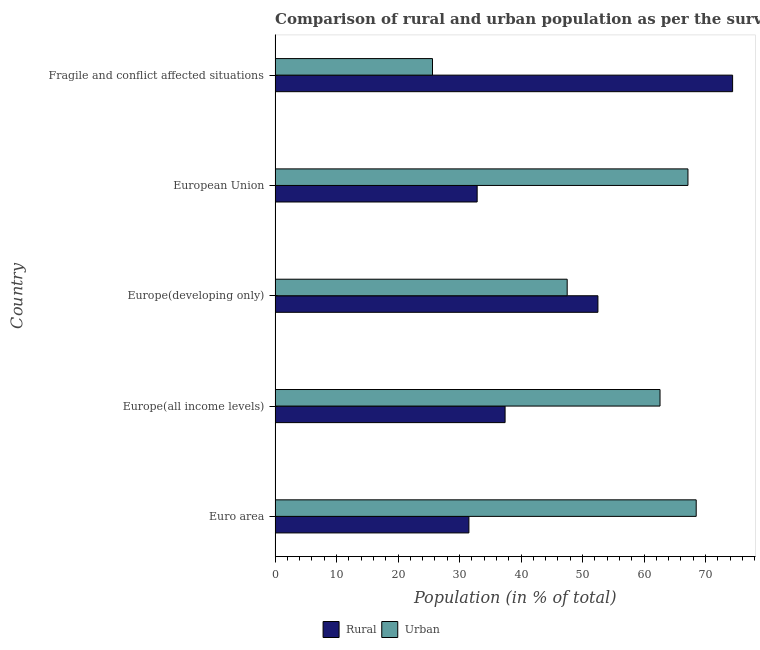How many bars are there on the 2nd tick from the top?
Make the answer very short. 2. What is the label of the 1st group of bars from the top?
Provide a succinct answer. Fragile and conflict affected situations. What is the urban population in European Union?
Provide a succinct answer. 67.14. Across all countries, what is the maximum rural population?
Make the answer very short. 74.4. Across all countries, what is the minimum rural population?
Provide a succinct answer. 31.52. In which country was the rural population maximum?
Offer a very short reply. Fragile and conflict affected situations. What is the total urban population in the graph?
Give a very brief answer. 271.32. What is the difference between the urban population in Europe(developing only) and that in European Union?
Your response must be concise. -19.64. What is the difference between the rural population in Europe(developing only) and the urban population in Fragile and conflict affected situations?
Ensure brevity in your answer.  26.9. What is the average rural population per country?
Provide a succinct answer. 45.74. What is the difference between the urban population and rural population in Europe(all income levels)?
Your answer should be very brief. 25.2. In how many countries, is the urban population greater than 34 %?
Give a very brief answer. 4. What is the ratio of the urban population in Euro area to that in Fragile and conflict affected situations?
Your answer should be very brief. 2.67. Is the difference between the urban population in Euro area and Europe(all income levels) greater than the difference between the rural population in Euro area and Europe(all income levels)?
Offer a terse response. Yes. What is the difference between the highest and the second highest urban population?
Ensure brevity in your answer.  1.34. What is the difference between the highest and the lowest urban population?
Offer a very short reply. 42.88. What does the 1st bar from the top in Europe(developing only) represents?
Ensure brevity in your answer.  Urban. What does the 1st bar from the bottom in Europe(developing only) represents?
Your response must be concise. Rural. What is the difference between two consecutive major ticks on the X-axis?
Provide a succinct answer. 10. Are the values on the major ticks of X-axis written in scientific E-notation?
Your answer should be very brief. No. What is the title of the graph?
Make the answer very short. Comparison of rural and urban population as per the survey in 1974 census. Does "Technicians" appear as one of the legend labels in the graph?
Your answer should be very brief. No. What is the label or title of the X-axis?
Provide a short and direct response. Population (in % of total). What is the label or title of the Y-axis?
Provide a succinct answer. Country. What is the Population (in % of total) of Rural in Euro area?
Give a very brief answer. 31.52. What is the Population (in % of total) in Urban in Euro area?
Provide a short and direct response. 68.48. What is the Population (in % of total) of Rural in Europe(all income levels)?
Make the answer very short. 37.4. What is the Population (in % of total) in Urban in Europe(all income levels)?
Ensure brevity in your answer.  62.6. What is the Population (in % of total) of Rural in Europe(developing only)?
Your answer should be compact. 52.5. What is the Population (in % of total) in Urban in Europe(developing only)?
Your answer should be very brief. 47.5. What is the Population (in % of total) of Rural in European Union?
Your answer should be very brief. 32.86. What is the Population (in % of total) of Urban in European Union?
Provide a short and direct response. 67.14. What is the Population (in % of total) of Rural in Fragile and conflict affected situations?
Make the answer very short. 74.4. What is the Population (in % of total) in Urban in Fragile and conflict affected situations?
Ensure brevity in your answer.  25.6. Across all countries, what is the maximum Population (in % of total) in Rural?
Keep it short and to the point. 74.4. Across all countries, what is the maximum Population (in % of total) of Urban?
Offer a terse response. 68.48. Across all countries, what is the minimum Population (in % of total) of Rural?
Make the answer very short. 31.52. Across all countries, what is the minimum Population (in % of total) of Urban?
Keep it short and to the point. 25.6. What is the total Population (in % of total) of Rural in the graph?
Offer a terse response. 228.68. What is the total Population (in % of total) in Urban in the graph?
Give a very brief answer. 271.32. What is the difference between the Population (in % of total) of Rural in Euro area and that in Europe(all income levels)?
Provide a short and direct response. -5.88. What is the difference between the Population (in % of total) in Urban in Euro area and that in Europe(all income levels)?
Offer a terse response. 5.88. What is the difference between the Population (in % of total) of Rural in Euro area and that in Europe(developing only)?
Offer a terse response. -20.98. What is the difference between the Population (in % of total) in Urban in Euro area and that in Europe(developing only)?
Offer a very short reply. 20.98. What is the difference between the Population (in % of total) in Rural in Euro area and that in European Union?
Provide a short and direct response. -1.34. What is the difference between the Population (in % of total) of Urban in Euro area and that in European Union?
Make the answer very short. 1.34. What is the difference between the Population (in % of total) in Rural in Euro area and that in Fragile and conflict affected situations?
Offer a very short reply. -42.88. What is the difference between the Population (in % of total) in Urban in Euro area and that in Fragile and conflict affected situations?
Provide a succinct answer. 42.88. What is the difference between the Population (in % of total) of Rural in Europe(all income levels) and that in Europe(developing only)?
Your answer should be compact. -15.1. What is the difference between the Population (in % of total) in Urban in Europe(all income levels) and that in Europe(developing only)?
Offer a terse response. 15.1. What is the difference between the Population (in % of total) in Rural in Europe(all income levels) and that in European Union?
Offer a very short reply. 4.54. What is the difference between the Population (in % of total) in Urban in Europe(all income levels) and that in European Union?
Offer a terse response. -4.54. What is the difference between the Population (in % of total) in Rural in Europe(all income levels) and that in Fragile and conflict affected situations?
Offer a very short reply. -37. What is the difference between the Population (in % of total) of Urban in Europe(all income levels) and that in Fragile and conflict affected situations?
Provide a short and direct response. 37. What is the difference between the Population (in % of total) in Rural in Europe(developing only) and that in European Union?
Your answer should be very brief. 19.64. What is the difference between the Population (in % of total) of Urban in Europe(developing only) and that in European Union?
Your response must be concise. -19.64. What is the difference between the Population (in % of total) of Rural in Europe(developing only) and that in Fragile and conflict affected situations?
Offer a terse response. -21.9. What is the difference between the Population (in % of total) in Urban in Europe(developing only) and that in Fragile and conflict affected situations?
Your answer should be very brief. 21.9. What is the difference between the Population (in % of total) in Rural in European Union and that in Fragile and conflict affected situations?
Provide a short and direct response. -41.54. What is the difference between the Population (in % of total) in Urban in European Union and that in Fragile and conflict affected situations?
Ensure brevity in your answer.  41.54. What is the difference between the Population (in % of total) of Rural in Euro area and the Population (in % of total) of Urban in Europe(all income levels)?
Offer a terse response. -31.08. What is the difference between the Population (in % of total) in Rural in Euro area and the Population (in % of total) in Urban in Europe(developing only)?
Keep it short and to the point. -15.98. What is the difference between the Population (in % of total) in Rural in Euro area and the Population (in % of total) in Urban in European Union?
Your response must be concise. -35.62. What is the difference between the Population (in % of total) of Rural in Euro area and the Population (in % of total) of Urban in Fragile and conflict affected situations?
Your answer should be very brief. 5.92. What is the difference between the Population (in % of total) of Rural in Europe(all income levels) and the Population (in % of total) of Urban in Europe(developing only)?
Give a very brief answer. -10.1. What is the difference between the Population (in % of total) in Rural in Europe(all income levels) and the Population (in % of total) in Urban in European Union?
Your answer should be compact. -29.74. What is the difference between the Population (in % of total) of Rural in Europe(all income levels) and the Population (in % of total) of Urban in Fragile and conflict affected situations?
Keep it short and to the point. 11.8. What is the difference between the Population (in % of total) in Rural in Europe(developing only) and the Population (in % of total) in Urban in European Union?
Provide a short and direct response. -14.64. What is the difference between the Population (in % of total) in Rural in Europe(developing only) and the Population (in % of total) in Urban in Fragile and conflict affected situations?
Your response must be concise. 26.9. What is the difference between the Population (in % of total) in Rural in European Union and the Population (in % of total) in Urban in Fragile and conflict affected situations?
Keep it short and to the point. 7.26. What is the average Population (in % of total) in Rural per country?
Provide a succinct answer. 45.74. What is the average Population (in % of total) in Urban per country?
Your answer should be very brief. 54.26. What is the difference between the Population (in % of total) of Rural and Population (in % of total) of Urban in Euro area?
Keep it short and to the point. -36.96. What is the difference between the Population (in % of total) of Rural and Population (in % of total) of Urban in Europe(all income levels)?
Ensure brevity in your answer.  -25.19. What is the difference between the Population (in % of total) in Rural and Population (in % of total) in Urban in Europe(developing only)?
Your response must be concise. 5. What is the difference between the Population (in % of total) in Rural and Population (in % of total) in Urban in European Union?
Provide a short and direct response. -34.28. What is the difference between the Population (in % of total) in Rural and Population (in % of total) in Urban in Fragile and conflict affected situations?
Give a very brief answer. 48.8. What is the ratio of the Population (in % of total) of Rural in Euro area to that in Europe(all income levels)?
Your answer should be very brief. 0.84. What is the ratio of the Population (in % of total) of Urban in Euro area to that in Europe(all income levels)?
Offer a very short reply. 1.09. What is the ratio of the Population (in % of total) in Rural in Euro area to that in Europe(developing only)?
Make the answer very short. 0.6. What is the ratio of the Population (in % of total) of Urban in Euro area to that in Europe(developing only)?
Provide a succinct answer. 1.44. What is the ratio of the Population (in % of total) of Rural in Euro area to that in European Union?
Offer a terse response. 0.96. What is the ratio of the Population (in % of total) of Rural in Euro area to that in Fragile and conflict affected situations?
Your response must be concise. 0.42. What is the ratio of the Population (in % of total) of Urban in Euro area to that in Fragile and conflict affected situations?
Your answer should be compact. 2.68. What is the ratio of the Population (in % of total) of Rural in Europe(all income levels) to that in Europe(developing only)?
Your answer should be very brief. 0.71. What is the ratio of the Population (in % of total) in Urban in Europe(all income levels) to that in Europe(developing only)?
Give a very brief answer. 1.32. What is the ratio of the Population (in % of total) of Rural in Europe(all income levels) to that in European Union?
Your answer should be very brief. 1.14. What is the ratio of the Population (in % of total) of Urban in Europe(all income levels) to that in European Union?
Your answer should be compact. 0.93. What is the ratio of the Population (in % of total) of Rural in Europe(all income levels) to that in Fragile and conflict affected situations?
Your answer should be compact. 0.5. What is the ratio of the Population (in % of total) of Urban in Europe(all income levels) to that in Fragile and conflict affected situations?
Give a very brief answer. 2.45. What is the ratio of the Population (in % of total) of Rural in Europe(developing only) to that in European Union?
Ensure brevity in your answer.  1.6. What is the ratio of the Population (in % of total) in Urban in Europe(developing only) to that in European Union?
Keep it short and to the point. 0.71. What is the ratio of the Population (in % of total) in Rural in Europe(developing only) to that in Fragile and conflict affected situations?
Offer a terse response. 0.71. What is the ratio of the Population (in % of total) in Urban in Europe(developing only) to that in Fragile and conflict affected situations?
Your answer should be compact. 1.86. What is the ratio of the Population (in % of total) of Rural in European Union to that in Fragile and conflict affected situations?
Your answer should be compact. 0.44. What is the ratio of the Population (in % of total) in Urban in European Union to that in Fragile and conflict affected situations?
Offer a terse response. 2.62. What is the difference between the highest and the second highest Population (in % of total) of Rural?
Your response must be concise. 21.9. What is the difference between the highest and the second highest Population (in % of total) of Urban?
Your response must be concise. 1.34. What is the difference between the highest and the lowest Population (in % of total) in Rural?
Provide a short and direct response. 42.88. What is the difference between the highest and the lowest Population (in % of total) of Urban?
Give a very brief answer. 42.88. 